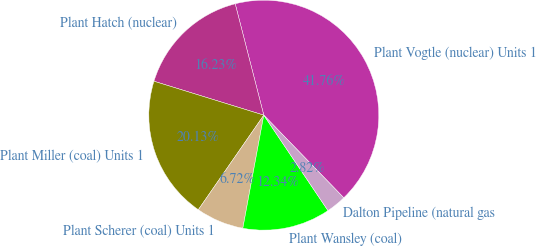Convert chart to OTSL. <chart><loc_0><loc_0><loc_500><loc_500><pie_chart><fcel>Plant Vogtle (nuclear) Units 1<fcel>Plant Hatch (nuclear)<fcel>Plant Miller (coal) Units 1<fcel>Plant Scherer (coal) Units 1<fcel>Plant Wansley (coal)<fcel>Dalton Pipeline (natural gas<nl><fcel>41.76%<fcel>16.23%<fcel>20.13%<fcel>6.72%<fcel>12.34%<fcel>2.82%<nl></chart> 